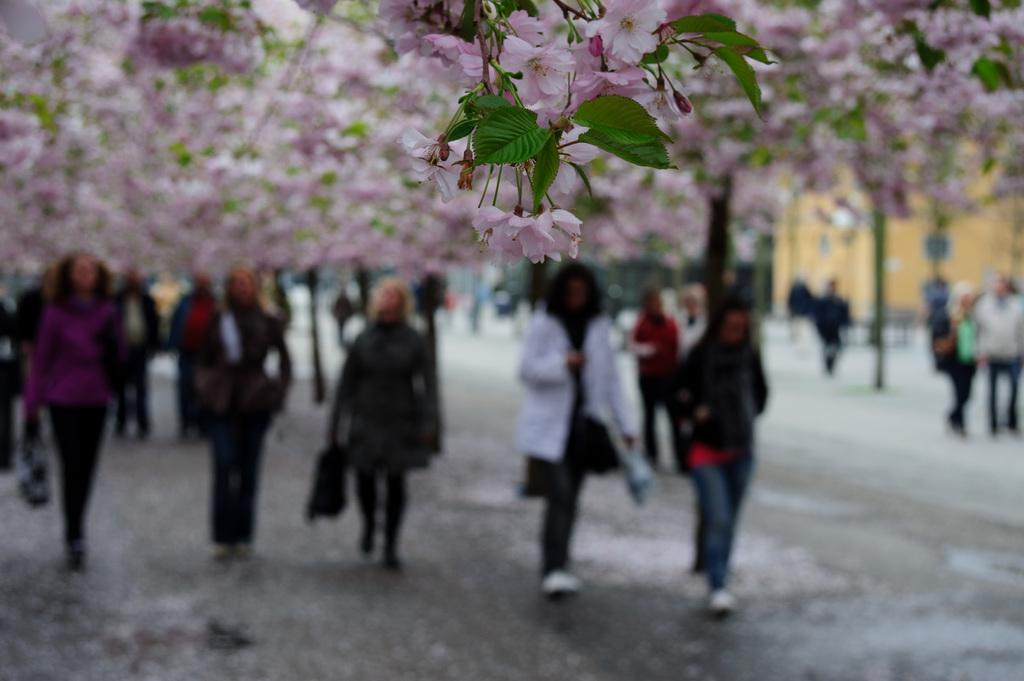What are the people in the image doing? The people in the image are walking. Where are the people walking? The people are walking on a road. What can be seen at the top of the image? There are flowers visible at the top of the image. How would you describe the quality of the image? The image is blurred. Where is the grandmother keeping her money in the image? There is no grandmother or money present in the image. What type of drawer can be seen in the image? There is no drawer present in the image. 